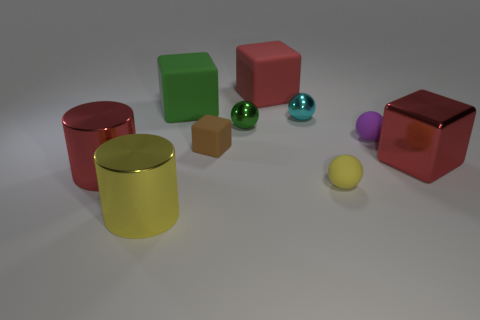Do the green thing that is behind the green metallic sphere and the tiny brown thing have the same shape?
Offer a terse response. Yes. What is the large red thing that is both on the right side of the green matte thing and in front of the small cyan ball made of?
Make the answer very short. Metal. There is a block that is on the right side of the purple thing; is there a large red rubber block to the right of it?
Ensure brevity in your answer.  No. How big is the object that is both to the left of the small matte block and behind the cyan thing?
Keep it short and to the point. Large. What number of yellow objects are either matte objects or tiny things?
Offer a very short reply. 1. The green thing that is the same size as the brown block is what shape?
Make the answer very short. Sphere. What number of other things are there of the same color as the large metal block?
Ensure brevity in your answer.  2. There is a red cube that is on the left side of the red block in front of the small brown thing; how big is it?
Your response must be concise. Large. Are the big red cube behind the large red metal block and the cyan ball made of the same material?
Provide a succinct answer. No. The red shiny object that is on the left side of the big red metal block has what shape?
Make the answer very short. Cylinder. 